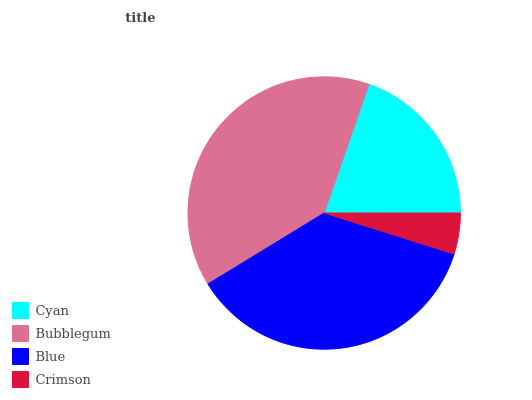Is Crimson the minimum?
Answer yes or no. Yes. Is Bubblegum the maximum?
Answer yes or no. Yes. Is Blue the minimum?
Answer yes or no. No. Is Blue the maximum?
Answer yes or no. No. Is Bubblegum greater than Blue?
Answer yes or no. Yes. Is Blue less than Bubblegum?
Answer yes or no. Yes. Is Blue greater than Bubblegum?
Answer yes or no. No. Is Bubblegum less than Blue?
Answer yes or no. No. Is Blue the high median?
Answer yes or no. Yes. Is Cyan the low median?
Answer yes or no. Yes. Is Crimson the high median?
Answer yes or no. No. Is Crimson the low median?
Answer yes or no. No. 